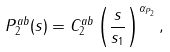<formula> <loc_0><loc_0><loc_500><loc_500>P _ { 2 } ^ { a b } ( s ) = C _ { 2 } ^ { a b } \left ( \frac { s } { s _ { 1 } } \right ) ^ { \alpha _ { P _ { 2 } } } ,</formula> 